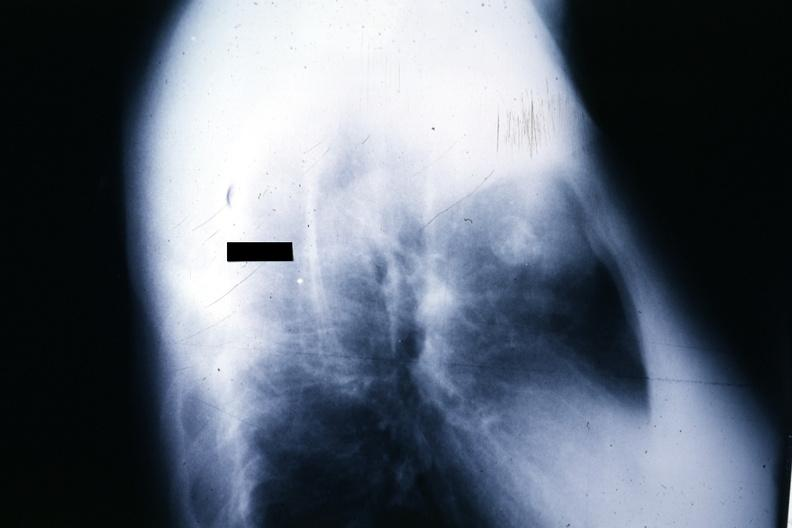what does this image show?
Answer the question using a single word or phrase. X-ray lateral view large mass anterior superior mediastinum source 